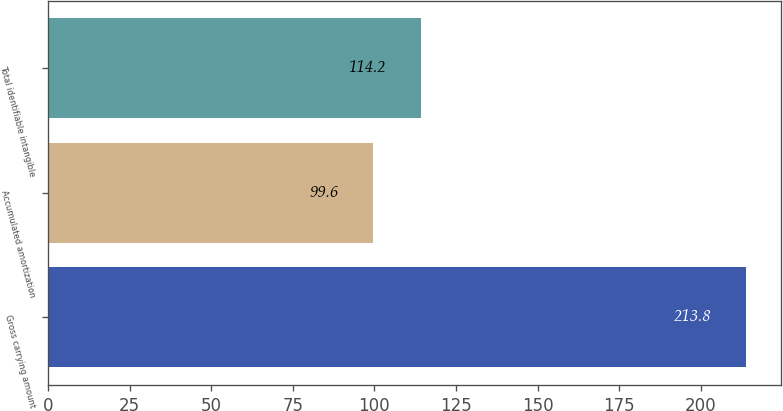<chart> <loc_0><loc_0><loc_500><loc_500><bar_chart><fcel>Gross carrying amount<fcel>Accumulated amortization<fcel>Total identifiable intangible<nl><fcel>213.8<fcel>99.6<fcel>114.2<nl></chart> 